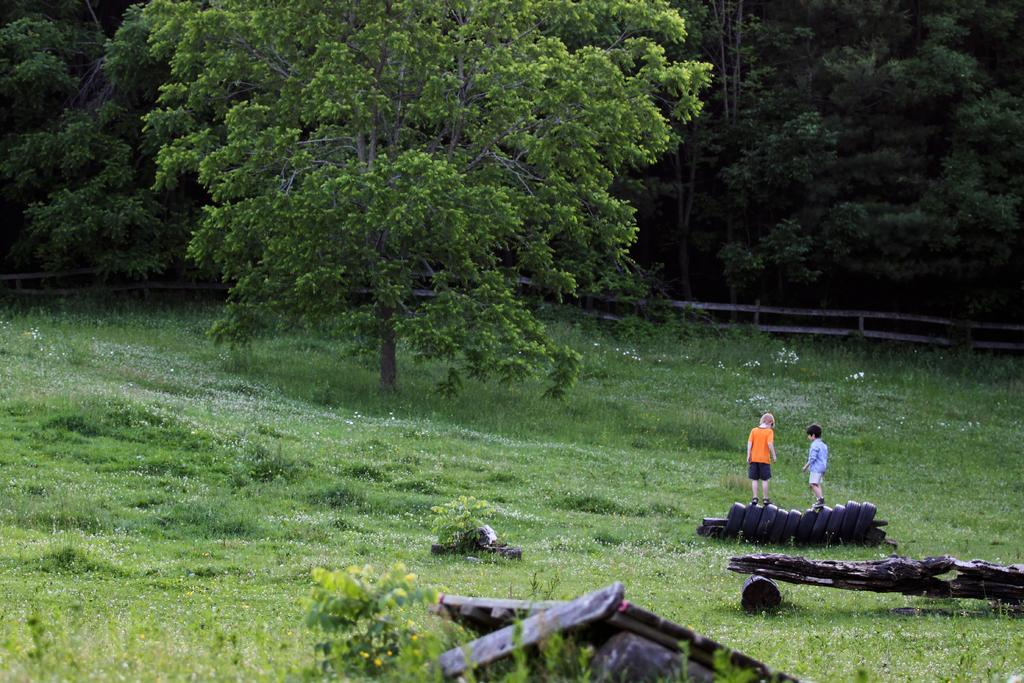What type of surface is visible in the image? There is a grass surface in the image. What are the two boys doing on the grass surface? The two boys are standing on tires in the image. What is located on the grass surface besides the boys? There is a tree on the grass surface. What can be seen in the background of the image? There are many trees visible behind a fencing in the image. Where is the desk located in the image? There is no desk present in the image. What type of island can be seen in the image? There is no island present in the image. 